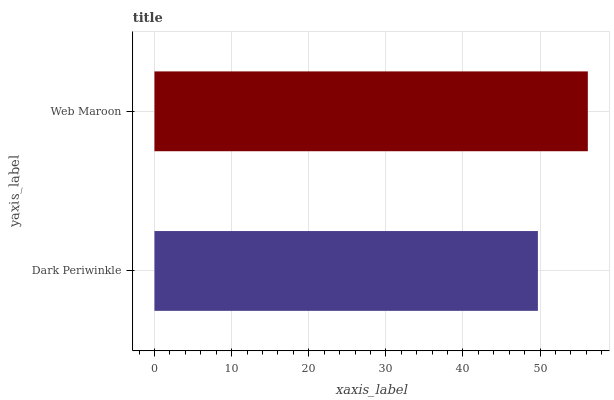Is Dark Periwinkle the minimum?
Answer yes or no. Yes. Is Web Maroon the maximum?
Answer yes or no. Yes. Is Web Maroon the minimum?
Answer yes or no. No. Is Web Maroon greater than Dark Periwinkle?
Answer yes or no. Yes. Is Dark Periwinkle less than Web Maroon?
Answer yes or no. Yes. Is Dark Periwinkle greater than Web Maroon?
Answer yes or no. No. Is Web Maroon less than Dark Periwinkle?
Answer yes or no. No. Is Web Maroon the high median?
Answer yes or no. Yes. Is Dark Periwinkle the low median?
Answer yes or no. Yes. Is Dark Periwinkle the high median?
Answer yes or no. No. Is Web Maroon the low median?
Answer yes or no. No. 